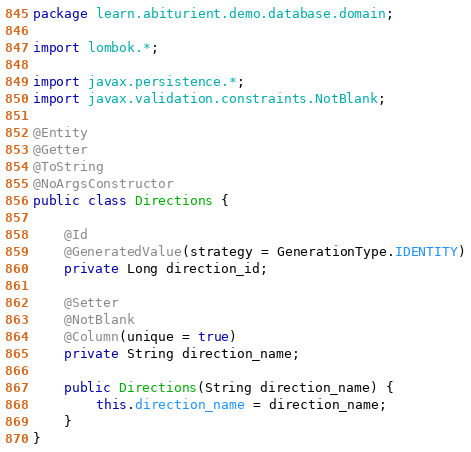<code> <loc_0><loc_0><loc_500><loc_500><_Java_>package learn.abiturient.demo.database.domain;

import lombok.*;

import javax.persistence.*;
import javax.validation.constraints.NotBlank;

@Entity
@Getter
@ToString
@NoArgsConstructor
public class Directions {

    @Id
    @GeneratedValue(strategy = GenerationType.IDENTITY)
    private Long direction_id;

    @Setter
    @NotBlank
    @Column(unique = true)
    private String direction_name;

    public Directions(String direction_name) {
        this.direction_name = direction_name;
    }
}
</code> 